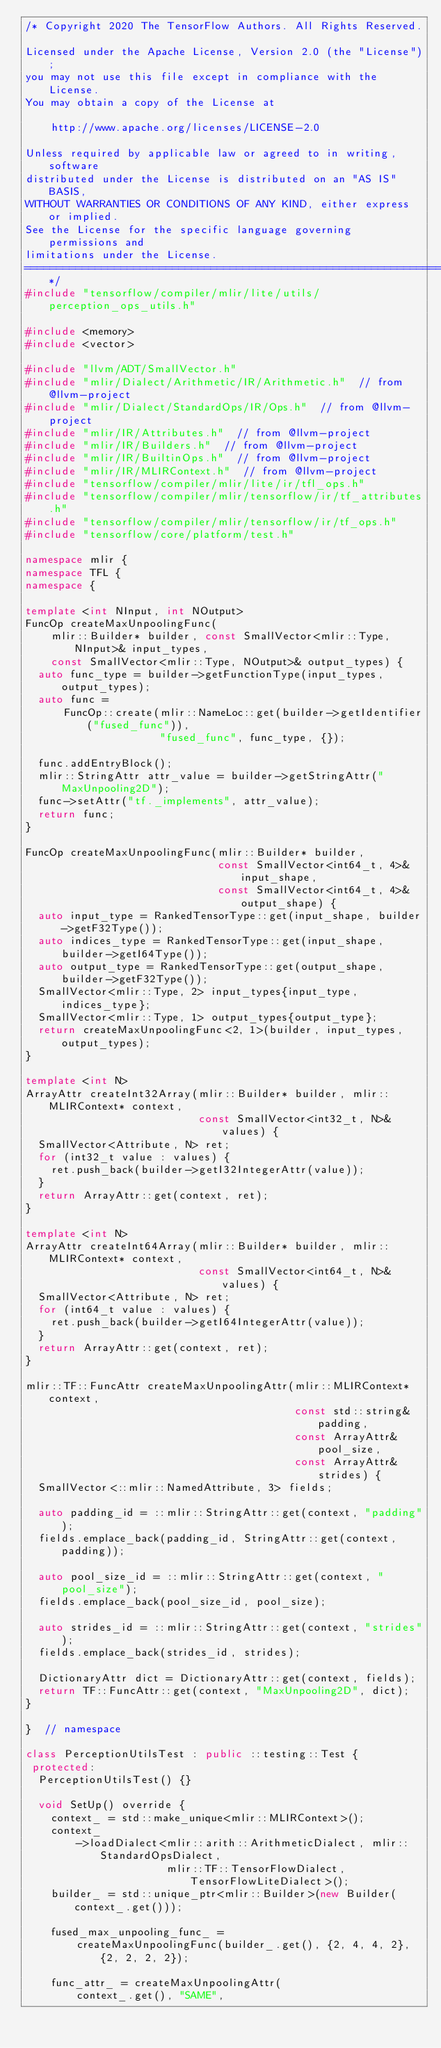<code> <loc_0><loc_0><loc_500><loc_500><_C++_>/* Copyright 2020 The TensorFlow Authors. All Rights Reserved.

Licensed under the Apache License, Version 2.0 (the "License");
you may not use this file except in compliance with the License.
You may obtain a copy of the License at

    http://www.apache.org/licenses/LICENSE-2.0

Unless required by applicable law or agreed to in writing, software
distributed under the License is distributed on an "AS IS" BASIS,
WITHOUT WARRANTIES OR CONDITIONS OF ANY KIND, either express or implied.
See the License for the specific language governing permissions and
limitations under the License.
==============================================================================*/
#include "tensorflow/compiler/mlir/lite/utils/perception_ops_utils.h"

#include <memory>
#include <vector>

#include "llvm/ADT/SmallVector.h"
#include "mlir/Dialect/Arithmetic/IR/Arithmetic.h"  // from @llvm-project
#include "mlir/Dialect/StandardOps/IR/Ops.h"  // from @llvm-project
#include "mlir/IR/Attributes.h"  // from @llvm-project
#include "mlir/IR/Builders.h"  // from @llvm-project
#include "mlir/IR/BuiltinOps.h"  // from @llvm-project
#include "mlir/IR/MLIRContext.h"  // from @llvm-project
#include "tensorflow/compiler/mlir/lite/ir/tfl_ops.h"
#include "tensorflow/compiler/mlir/tensorflow/ir/tf_attributes.h"
#include "tensorflow/compiler/mlir/tensorflow/ir/tf_ops.h"
#include "tensorflow/core/platform/test.h"

namespace mlir {
namespace TFL {
namespace {

template <int NInput, int NOutput>
FuncOp createMaxUnpoolingFunc(
    mlir::Builder* builder, const SmallVector<mlir::Type, NInput>& input_types,
    const SmallVector<mlir::Type, NOutput>& output_types) {
  auto func_type = builder->getFunctionType(input_types, output_types);
  auto func =
      FuncOp::create(mlir::NameLoc::get(builder->getIdentifier("fused_func")),
                     "fused_func", func_type, {});

  func.addEntryBlock();
  mlir::StringAttr attr_value = builder->getStringAttr("MaxUnpooling2D");
  func->setAttr("tf._implements", attr_value);
  return func;
}

FuncOp createMaxUnpoolingFunc(mlir::Builder* builder,
                              const SmallVector<int64_t, 4>& input_shape,
                              const SmallVector<int64_t, 4>& output_shape) {
  auto input_type = RankedTensorType::get(input_shape, builder->getF32Type());
  auto indices_type = RankedTensorType::get(input_shape, builder->getI64Type());
  auto output_type = RankedTensorType::get(output_shape, builder->getF32Type());
  SmallVector<mlir::Type, 2> input_types{input_type, indices_type};
  SmallVector<mlir::Type, 1> output_types{output_type};
  return createMaxUnpoolingFunc<2, 1>(builder, input_types, output_types);
}

template <int N>
ArrayAttr createInt32Array(mlir::Builder* builder, mlir::MLIRContext* context,
                           const SmallVector<int32_t, N>& values) {
  SmallVector<Attribute, N> ret;
  for (int32_t value : values) {
    ret.push_back(builder->getI32IntegerAttr(value));
  }
  return ArrayAttr::get(context, ret);
}

template <int N>
ArrayAttr createInt64Array(mlir::Builder* builder, mlir::MLIRContext* context,
                           const SmallVector<int64_t, N>& values) {
  SmallVector<Attribute, N> ret;
  for (int64_t value : values) {
    ret.push_back(builder->getI64IntegerAttr(value));
  }
  return ArrayAttr::get(context, ret);
}

mlir::TF::FuncAttr createMaxUnpoolingAttr(mlir::MLIRContext* context,
                                          const std::string& padding,
                                          const ArrayAttr& pool_size,
                                          const ArrayAttr& strides) {
  SmallVector<::mlir::NamedAttribute, 3> fields;

  auto padding_id = ::mlir::StringAttr::get(context, "padding");
  fields.emplace_back(padding_id, StringAttr::get(context, padding));

  auto pool_size_id = ::mlir::StringAttr::get(context, "pool_size");
  fields.emplace_back(pool_size_id, pool_size);

  auto strides_id = ::mlir::StringAttr::get(context, "strides");
  fields.emplace_back(strides_id, strides);

  DictionaryAttr dict = DictionaryAttr::get(context, fields);
  return TF::FuncAttr::get(context, "MaxUnpooling2D", dict);
}

}  // namespace

class PerceptionUtilsTest : public ::testing::Test {
 protected:
  PerceptionUtilsTest() {}

  void SetUp() override {
    context_ = std::make_unique<mlir::MLIRContext>();
    context_
        ->loadDialect<mlir::arith::ArithmeticDialect, mlir::StandardOpsDialect,
                      mlir::TF::TensorFlowDialect, TensorFlowLiteDialect>();
    builder_ = std::unique_ptr<mlir::Builder>(new Builder(context_.get()));

    fused_max_unpooling_func_ =
        createMaxUnpoolingFunc(builder_.get(), {2, 4, 4, 2}, {2, 2, 2, 2});

    func_attr_ = createMaxUnpoolingAttr(
        context_.get(), "SAME",</code> 